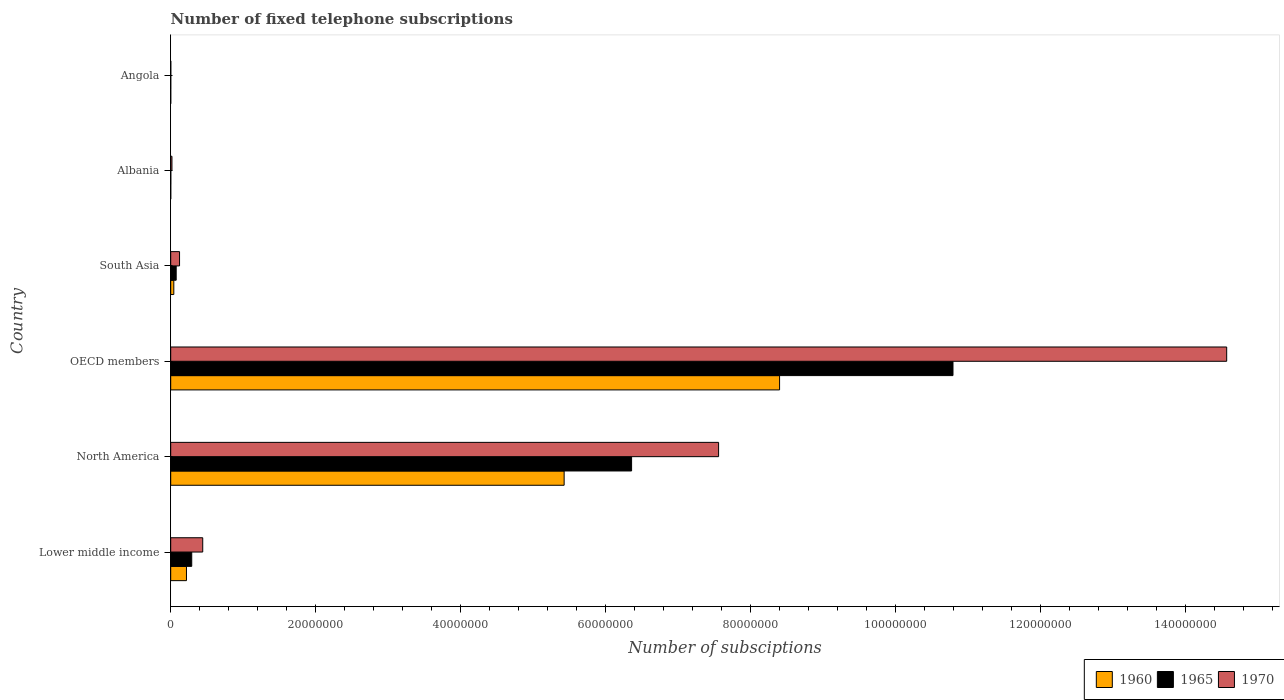How many different coloured bars are there?
Provide a short and direct response. 3. Are the number of bars per tick equal to the number of legend labels?
Your response must be concise. Yes. What is the label of the 4th group of bars from the top?
Offer a very short reply. OECD members. What is the number of fixed telephone subscriptions in 1960 in Lower middle income?
Keep it short and to the point. 2.17e+06. Across all countries, what is the maximum number of fixed telephone subscriptions in 1965?
Your response must be concise. 1.08e+08. Across all countries, what is the minimum number of fixed telephone subscriptions in 1970?
Offer a terse response. 1.30e+04. In which country was the number of fixed telephone subscriptions in 1965 maximum?
Your response must be concise. OECD members. In which country was the number of fixed telephone subscriptions in 1970 minimum?
Make the answer very short. Angola. What is the total number of fixed telephone subscriptions in 1965 in the graph?
Your answer should be very brief. 1.75e+08. What is the difference between the number of fixed telephone subscriptions in 1965 in Angola and that in North America?
Make the answer very short. -6.36e+07. What is the difference between the number of fixed telephone subscriptions in 1970 in Albania and the number of fixed telephone subscriptions in 1965 in South Asia?
Offer a very short reply. -5.84e+05. What is the average number of fixed telephone subscriptions in 1965 per country?
Offer a terse response. 2.92e+07. What is the difference between the number of fixed telephone subscriptions in 1970 and number of fixed telephone subscriptions in 1965 in OECD members?
Ensure brevity in your answer.  3.78e+07. In how many countries, is the number of fixed telephone subscriptions in 1960 greater than 148000000 ?
Offer a very short reply. 0. What is the ratio of the number of fixed telephone subscriptions in 1960 in North America to that in OECD members?
Provide a short and direct response. 0.65. Is the number of fixed telephone subscriptions in 1970 in Lower middle income less than that in South Asia?
Your response must be concise. No. What is the difference between the highest and the second highest number of fixed telephone subscriptions in 1960?
Your answer should be compact. 2.97e+07. What is the difference between the highest and the lowest number of fixed telephone subscriptions in 1970?
Your response must be concise. 1.46e+08. In how many countries, is the number of fixed telephone subscriptions in 1960 greater than the average number of fixed telephone subscriptions in 1960 taken over all countries?
Offer a very short reply. 2. What does the 1st bar from the top in North America represents?
Ensure brevity in your answer.  1970. What does the 2nd bar from the bottom in North America represents?
Ensure brevity in your answer.  1965. Are all the bars in the graph horizontal?
Keep it short and to the point. Yes. What is the difference between two consecutive major ticks on the X-axis?
Make the answer very short. 2.00e+07. Are the values on the major ticks of X-axis written in scientific E-notation?
Provide a succinct answer. No. Does the graph contain any zero values?
Your answer should be compact. No. Where does the legend appear in the graph?
Make the answer very short. Bottom right. What is the title of the graph?
Your answer should be compact. Number of fixed telephone subscriptions. What is the label or title of the X-axis?
Ensure brevity in your answer.  Number of subsciptions. What is the label or title of the Y-axis?
Your response must be concise. Country. What is the Number of subsciptions in 1960 in Lower middle income?
Offer a terse response. 2.17e+06. What is the Number of subsciptions in 1965 in Lower middle income?
Keep it short and to the point. 2.90e+06. What is the Number of subsciptions in 1970 in Lower middle income?
Provide a succinct answer. 4.42e+06. What is the Number of subsciptions in 1960 in North America?
Your answer should be very brief. 5.43e+07. What is the Number of subsciptions of 1965 in North America?
Keep it short and to the point. 6.36e+07. What is the Number of subsciptions in 1970 in North America?
Offer a very short reply. 7.56e+07. What is the Number of subsciptions of 1960 in OECD members?
Offer a very short reply. 8.40e+07. What is the Number of subsciptions in 1965 in OECD members?
Your response must be concise. 1.08e+08. What is the Number of subsciptions of 1970 in OECD members?
Offer a very short reply. 1.46e+08. What is the Number of subsciptions of 1960 in South Asia?
Offer a very short reply. 4.30e+05. What is the Number of subsciptions of 1965 in South Asia?
Keep it short and to the point. 7.57e+05. What is the Number of subsciptions of 1970 in South Asia?
Offer a very short reply. 1.22e+06. What is the Number of subsciptions of 1960 in Albania?
Keep it short and to the point. 6845. What is the Number of subsciptions in 1965 in Albania?
Your response must be concise. 1.40e+04. What is the Number of subsciptions in 1970 in Albania?
Provide a short and direct response. 1.73e+05. What is the Number of subsciptions in 1960 in Angola?
Your response must be concise. 6666. What is the Number of subsciptions of 1965 in Angola?
Give a very brief answer. 10000. What is the Number of subsciptions of 1970 in Angola?
Your answer should be very brief. 1.30e+04. Across all countries, what is the maximum Number of subsciptions of 1960?
Ensure brevity in your answer.  8.40e+07. Across all countries, what is the maximum Number of subsciptions in 1965?
Your answer should be very brief. 1.08e+08. Across all countries, what is the maximum Number of subsciptions of 1970?
Offer a very short reply. 1.46e+08. Across all countries, what is the minimum Number of subsciptions of 1960?
Give a very brief answer. 6666. Across all countries, what is the minimum Number of subsciptions in 1965?
Your answer should be compact. 10000. Across all countries, what is the minimum Number of subsciptions of 1970?
Offer a terse response. 1.30e+04. What is the total Number of subsciptions in 1960 in the graph?
Keep it short and to the point. 1.41e+08. What is the total Number of subsciptions of 1965 in the graph?
Offer a very short reply. 1.75e+08. What is the total Number of subsciptions of 1970 in the graph?
Offer a very short reply. 2.27e+08. What is the difference between the Number of subsciptions in 1960 in Lower middle income and that in North America?
Provide a short and direct response. -5.21e+07. What is the difference between the Number of subsciptions in 1965 in Lower middle income and that in North America?
Provide a short and direct response. -6.07e+07. What is the difference between the Number of subsciptions in 1970 in Lower middle income and that in North America?
Give a very brief answer. -7.12e+07. What is the difference between the Number of subsciptions in 1960 in Lower middle income and that in OECD members?
Give a very brief answer. -8.18e+07. What is the difference between the Number of subsciptions in 1965 in Lower middle income and that in OECD members?
Your answer should be very brief. -1.05e+08. What is the difference between the Number of subsciptions in 1970 in Lower middle income and that in OECD members?
Your answer should be compact. -1.41e+08. What is the difference between the Number of subsciptions in 1960 in Lower middle income and that in South Asia?
Make the answer very short. 1.74e+06. What is the difference between the Number of subsciptions in 1965 in Lower middle income and that in South Asia?
Your answer should be very brief. 2.14e+06. What is the difference between the Number of subsciptions of 1970 in Lower middle income and that in South Asia?
Give a very brief answer. 3.20e+06. What is the difference between the Number of subsciptions in 1960 in Lower middle income and that in Albania?
Provide a succinct answer. 2.17e+06. What is the difference between the Number of subsciptions of 1965 in Lower middle income and that in Albania?
Offer a very short reply. 2.89e+06. What is the difference between the Number of subsciptions of 1970 in Lower middle income and that in Albania?
Your response must be concise. 4.25e+06. What is the difference between the Number of subsciptions of 1960 in Lower middle income and that in Angola?
Provide a succinct answer. 2.17e+06. What is the difference between the Number of subsciptions in 1965 in Lower middle income and that in Angola?
Offer a very short reply. 2.89e+06. What is the difference between the Number of subsciptions of 1970 in Lower middle income and that in Angola?
Provide a succinct answer. 4.41e+06. What is the difference between the Number of subsciptions of 1960 in North America and that in OECD members?
Make the answer very short. -2.97e+07. What is the difference between the Number of subsciptions of 1965 in North America and that in OECD members?
Keep it short and to the point. -4.43e+07. What is the difference between the Number of subsciptions of 1970 in North America and that in OECD members?
Your response must be concise. -7.01e+07. What is the difference between the Number of subsciptions in 1960 in North America and that in South Asia?
Provide a succinct answer. 5.38e+07. What is the difference between the Number of subsciptions of 1965 in North America and that in South Asia?
Provide a short and direct response. 6.28e+07. What is the difference between the Number of subsciptions in 1970 in North America and that in South Asia?
Give a very brief answer. 7.43e+07. What is the difference between the Number of subsciptions of 1960 in North America and that in Albania?
Give a very brief answer. 5.43e+07. What is the difference between the Number of subsciptions in 1965 in North America and that in Albania?
Your answer should be compact. 6.36e+07. What is the difference between the Number of subsciptions in 1970 in North America and that in Albania?
Provide a succinct answer. 7.54e+07. What is the difference between the Number of subsciptions in 1960 in North America and that in Angola?
Your answer should be very brief. 5.43e+07. What is the difference between the Number of subsciptions of 1965 in North America and that in Angola?
Ensure brevity in your answer.  6.36e+07. What is the difference between the Number of subsciptions of 1970 in North America and that in Angola?
Provide a short and direct response. 7.56e+07. What is the difference between the Number of subsciptions of 1960 in OECD members and that in South Asia?
Offer a very short reply. 8.36e+07. What is the difference between the Number of subsciptions of 1965 in OECD members and that in South Asia?
Offer a very short reply. 1.07e+08. What is the difference between the Number of subsciptions of 1970 in OECD members and that in South Asia?
Your answer should be compact. 1.44e+08. What is the difference between the Number of subsciptions of 1960 in OECD members and that in Albania?
Make the answer very short. 8.40e+07. What is the difference between the Number of subsciptions in 1965 in OECD members and that in Albania?
Provide a succinct answer. 1.08e+08. What is the difference between the Number of subsciptions in 1970 in OECD members and that in Albania?
Provide a succinct answer. 1.45e+08. What is the difference between the Number of subsciptions in 1960 in OECD members and that in Angola?
Your answer should be very brief. 8.40e+07. What is the difference between the Number of subsciptions of 1965 in OECD members and that in Angola?
Your answer should be compact. 1.08e+08. What is the difference between the Number of subsciptions of 1970 in OECD members and that in Angola?
Your response must be concise. 1.46e+08. What is the difference between the Number of subsciptions in 1960 in South Asia and that in Albania?
Ensure brevity in your answer.  4.23e+05. What is the difference between the Number of subsciptions of 1965 in South Asia and that in Albania?
Your response must be concise. 7.43e+05. What is the difference between the Number of subsciptions of 1970 in South Asia and that in Albania?
Provide a succinct answer. 1.05e+06. What is the difference between the Number of subsciptions in 1960 in South Asia and that in Angola?
Provide a short and direct response. 4.23e+05. What is the difference between the Number of subsciptions of 1965 in South Asia and that in Angola?
Offer a terse response. 7.47e+05. What is the difference between the Number of subsciptions in 1970 in South Asia and that in Angola?
Provide a succinct answer. 1.21e+06. What is the difference between the Number of subsciptions in 1960 in Albania and that in Angola?
Ensure brevity in your answer.  179. What is the difference between the Number of subsciptions of 1965 in Albania and that in Angola?
Offer a very short reply. 3991. What is the difference between the Number of subsciptions in 1970 in Albania and that in Angola?
Give a very brief answer. 1.60e+05. What is the difference between the Number of subsciptions in 1960 in Lower middle income and the Number of subsciptions in 1965 in North America?
Offer a terse response. -6.14e+07. What is the difference between the Number of subsciptions in 1960 in Lower middle income and the Number of subsciptions in 1970 in North America?
Keep it short and to the point. -7.34e+07. What is the difference between the Number of subsciptions in 1965 in Lower middle income and the Number of subsciptions in 1970 in North America?
Give a very brief answer. -7.27e+07. What is the difference between the Number of subsciptions of 1960 in Lower middle income and the Number of subsciptions of 1965 in OECD members?
Your answer should be very brief. -1.06e+08. What is the difference between the Number of subsciptions in 1960 in Lower middle income and the Number of subsciptions in 1970 in OECD members?
Provide a short and direct response. -1.43e+08. What is the difference between the Number of subsciptions of 1965 in Lower middle income and the Number of subsciptions of 1970 in OECD members?
Ensure brevity in your answer.  -1.43e+08. What is the difference between the Number of subsciptions in 1960 in Lower middle income and the Number of subsciptions in 1965 in South Asia?
Give a very brief answer. 1.42e+06. What is the difference between the Number of subsciptions of 1960 in Lower middle income and the Number of subsciptions of 1970 in South Asia?
Your answer should be compact. 9.54e+05. What is the difference between the Number of subsciptions in 1965 in Lower middle income and the Number of subsciptions in 1970 in South Asia?
Your answer should be very brief. 1.68e+06. What is the difference between the Number of subsciptions of 1960 in Lower middle income and the Number of subsciptions of 1965 in Albania?
Ensure brevity in your answer.  2.16e+06. What is the difference between the Number of subsciptions in 1960 in Lower middle income and the Number of subsciptions in 1970 in Albania?
Your response must be concise. 2.00e+06. What is the difference between the Number of subsciptions of 1965 in Lower middle income and the Number of subsciptions of 1970 in Albania?
Your response must be concise. 2.73e+06. What is the difference between the Number of subsciptions of 1960 in Lower middle income and the Number of subsciptions of 1965 in Angola?
Keep it short and to the point. 2.16e+06. What is the difference between the Number of subsciptions of 1960 in Lower middle income and the Number of subsciptions of 1970 in Angola?
Your answer should be compact. 2.16e+06. What is the difference between the Number of subsciptions in 1965 in Lower middle income and the Number of subsciptions in 1970 in Angola?
Make the answer very short. 2.89e+06. What is the difference between the Number of subsciptions of 1960 in North America and the Number of subsciptions of 1965 in OECD members?
Offer a terse response. -5.36e+07. What is the difference between the Number of subsciptions of 1960 in North America and the Number of subsciptions of 1970 in OECD members?
Give a very brief answer. -9.14e+07. What is the difference between the Number of subsciptions in 1965 in North America and the Number of subsciptions in 1970 in OECD members?
Ensure brevity in your answer.  -8.21e+07. What is the difference between the Number of subsciptions in 1960 in North America and the Number of subsciptions in 1965 in South Asia?
Your answer should be very brief. 5.35e+07. What is the difference between the Number of subsciptions in 1960 in North America and the Number of subsciptions in 1970 in South Asia?
Keep it short and to the point. 5.30e+07. What is the difference between the Number of subsciptions of 1965 in North America and the Number of subsciptions of 1970 in South Asia?
Your answer should be very brief. 6.24e+07. What is the difference between the Number of subsciptions in 1960 in North America and the Number of subsciptions in 1965 in Albania?
Offer a very short reply. 5.43e+07. What is the difference between the Number of subsciptions of 1960 in North America and the Number of subsciptions of 1970 in Albania?
Keep it short and to the point. 5.41e+07. What is the difference between the Number of subsciptions in 1965 in North America and the Number of subsciptions in 1970 in Albania?
Your response must be concise. 6.34e+07. What is the difference between the Number of subsciptions in 1960 in North America and the Number of subsciptions in 1965 in Angola?
Offer a terse response. 5.43e+07. What is the difference between the Number of subsciptions in 1960 in North America and the Number of subsciptions in 1970 in Angola?
Your response must be concise. 5.43e+07. What is the difference between the Number of subsciptions in 1965 in North America and the Number of subsciptions in 1970 in Angola?
Your response must be concise. 6.36e+07. What is the difference between the Number of subsciptions in 1960 in OECD members and the Number of subsciptions in 1965 in South Asia?
Make the answer very short. 8.32e+07. What is the difference between the Number of subsciptions of 1960 in OECD members and the Number of subsciptions of 1970 in South Asia?
Make the answer very short. 8.28e+07. What is the difference between the Number of subsciptions of 1965 in OECD members and the Number of subsciptions of 1970 in South Asia?
Provide a succinct answer. 1.07e+08. What is the difference between the Number of subsciptions in 1960 in OECD members and the Number of subsciptions in 1965 in Albania?
Your answer should be compact. 8.40e+07. What is the difference between the Number of subsciptions in 1960 in OECD members and the Number of subsciptions in 1970 in Albania?
Provide a short and direct response. 8.38e+07. What is the difference between the Number of subsciptions in 1965 in OECD members and the Number of subsciptions in 1970 in Albania?
Provide a short and direct response. 1.08e+08. What is the difference between the Number of subsciptions in 1960 in OECD members and the Number of subsciptions in 1965 in Angola?
Offer a terse response. 8.40e+07. What is the difference between the Number of subsciptions in 1960 in OECD members and the Number of subsciptions in 1970 in Angola?
Provide a short and direct response. 8.40e+07. What is the difference between the Number of subsciptions of 1965 in OECD members and the Number of subsciptions of 1970 in Angola?
Your answer should be compact. 1.08e+08. What is the difference between the Number of subsciptions in 1960 in South Asia and the Number of subsciptions in 1965 in Albania?
Give a very brief answer. 4.16e+05. What is the difference between the Number of subsciptions in 1960 in South Asia and the Number of subsciptions in 1970 in Albania?
Your answer should be compact. 2.57e+05. What is the difference between the Number of subsciptions in 1965 in South Asia and the Number of subsciptions in 1970 in Albania?
Offer a very short reply. 5.84e+05. What is the difference between the Number of subsciptions of 1960 in South Asia and the Number of subsciptions of 1965 in Angola?
Offer a terse response. 4.20e+05. What is the difference between the Number of subsciptions in 1960 in South Asia and the Number of subsciptions in 1970 in Angola?
Make the answer very short. 4.17e+05. What is the difference between the Number of subsciptions of 1965 in South Asia and the Number of subsciptions of 1970 in Angola?
Keep it short and to the point. 7.44e+05. What is the difference between the Number of subsciptions in 1960 in Albania and the Number of subsciptions in 1965 in Angola?
Give a very brief answer. -3155. What is the difference between the Number of subsciptions in 1960 in Albania and the Number of subsciptions in 1970 in Angola?
Offer a terse response. -6155. What is the difference between the Number of subsciptions in 1965 in Albania and the Number of subsciptions in 1970 in Angola?
Provide a succinct answer. 991. What is the average Number of subsciptions in 1960 per country?
Your answer should be very brief. 2.35e+07. What is the average Number of subsciptions of 1965 per country?
Your response must be concise. 2.92e+07. What is the average Number of subsciptions of 1970 per country?
Your answer should be compact. 3.78e+07. What is the difference between the Number of subsciptions of 1960 and Number of subsciptions of 1965 in Lower middle income?
Offer a very short reply. -7.27e+05. What is the difference between the Number of subsciptions of 1960 and Number of subsciptions of 1970 in Lower middle income?
Your response must be concise. -2.24e+06. What is the difference between the Number of subsciptions in 1965 and Number of subsciptions in 1970 in Lower middle income?
Offer a very short reply. -1.52e+06. What is the difference between the Number of subsciptions in 1960 and Number of subsciptions in 1965 in North America?
Your answer should be very brief. -9.30e+06. What is the difference between the Number of subsciptions of 1960 and Number of subsciptions of 1970 in North America?
Make the answer very short. -2.13e+07. What is the difference between the Number of subsciptions in 1965 and Number of subsciptions in 1970 in North America?
Make the answer very short. -1.20e+07. What is the difference between the Number of subsciptions in 1960 and Number of subsciptions in 1965 in OECD members?
Give a very brief answer. -2.39e+07. What is the difference between the Number of subsciptions in 1960 and Number of subsciptions in 1970 in OECD members?
Your response must be concise. -6.17e+07. What is the difference between the Number of subsciptions of 1965 and Number of subsciptions of 1970 in OECD members?
Your answer should be compact. -3.78e+07. What is the difference between the Number of subsciptions of 1960 and Number of subsciptions of 1965 in South Asia?
Your answer should be very brief. -3.27e+05. What is the difference between the Number of subsciptions of 1960 and Number of subsciptions of 1970 in South Asia?
Offer a very short reply. -7.90e+05. What is the difference between the Number of subsciptions of 1965 and Number of subsciptions of 1970 in South Asia?
Your answer should be compact. -4.63e+05. What is the difference between the Number of subsciptions of 1960 and Number of subsciptions of 1965 in Albania?
Ensure brevity in your answer.  -7146. What is the difference between the Number of subsciptions in 1960 and Number of subsciptions in 1970 in Albania?
Provide a succinct answer. -1.66e+05. What is the difference between the Number of subsciptions of 1965 and Number of subsciptions of 1970 in Albania?
Provide a succinct answer. -1.59e+05. What is the difference between the Number of subsciptions in 1960 and Number of subsciptions in 1965 in Angola?
Offer a terse response. -3334. What is the difference between the Number of subsciptions of 1960 and Number of subsciptions of 1970 in Angola?
Provide a short and direct response. -6334. What is the difference between the Number of subsciptions in 1965 and Number of subsciptions in 1970 in Angola?
Give a very brief answer. -3000. What is the ratio of the Number of subsciptions of 1960 in Lower middle income to that in North America?
Your response must be concise. 0.04. What is the ratio of the Number of subsciptions in 1965 in Lower middle income to that in North America?
Keep it short and to the point. 0.05. What is the ratio of the Number of subsciptions in 1970 in Lower middle income to that in North America?
Provide a short and direct response. 0.06. What is the ratio of the Number of subsciptions in 1960 in Lower middle income to that in OECD members?
Ensure brevity in your answer.  0.03. What is the ratio of the Number of subsciptions of 1965 in Lower middle income to that in OECD members?
Ensure brevity in your answer.  0.03. What is the ratio of the Number of subsciptions in 1970 in Lower middle income to that in OECD members?
Offer a terse response. 0.03. What is the ratio of the Number of subsciptions of 1960 in Lower middle income to that in South Asia?
Give a very brief answer. 5.06. What is the ratio of the Number of subsciptions of 1965 in Lower middle income to that in South Asia?
Offer a terse response. 3.83. What is the ratio of the Number of subsciptions of 1970 in Lower middle income to that in South Asia?
Offer a terse response. 3.62. What is the ratio of the Number of subsciptions of 1960 in Lower middle income to that in Albania?
Provide a succinct answer. 317.63. What is the ratio of the Number of subsciptions of 1965 in Lower middle income to that in Albania?
Make the answer very short. 207.34. What is the ratio of the Number of subsciptions in 1970 in Lower middle income to that in Albania?
Offer a terse response. 25.54. What is the ratio of the Number of subsciptions of 1960 in Lower middle income to that in Angola?
Offer a terse response. 326.16. What is the ratio of the Number of subsciptions of 1965 in Lower middle income to that in Angola?
Your answer should be very brief. 290.09. What is the ratio of the Number of subsciptions in 1970 in Lower middle income to that in Angola?
Make the answer very short. 339.85. What is the ratio of the Number of subsciptions in 1960 in North America to that in OECD members?
Provide a short and direct response. 0.65. What is the ratio of the Number of subsciptions in 1965 in North America to that in OECD members?
Keep it short and to the point. 0.59. What is the ratio of the Number of subsciptions in 1970 in North America to that in OECD members?
Keep it short and to the point. 0.52. What is the ratio of the Number of subsciptions of 1960 in North America to that in South Asia?
Your response must be concise. 126.3. What is the ratio of the Number of subsciptions in 1965 in North America to that in South Asia?
Offer a very short reply. 84.02. What is the ratio of the Number of subsciptions in 1970 in North America to that in South Asia?
Make the answer very short. 61.94. What is the ratio of the Number of subsciptions in 1960 in North America to that in Albania?
Offer a terse response. 7927.8. What is the ratio of the Number of subsciptions of 1965 in North America to that in Albania?
Offer a terse response. 4543.67. What is the ratio of the Number of subsciptions in 1970 in North America to that in Albania?
Ensure brevity in your answer.  436.82. What is the ratio of the Number of subsciptions of 1960 in North America to that in Angola?
Make the answer very short. 8140.68. What is the ratio of the Number of subsciptions in 1965 in North America to that in Angola?
Offer a very short reply. 6357.05. What is the ratio of the Number of subsciptions in 1970 in North America to that in Angola?
Your answer should be very brief. 5813. What is the ratio of the Number of subsciptions of 1960 in OECD members to that in South Asia?
Give a very brief answer. 195.46. What is the ratio of the Number of subsciptions of 1965 in OECD members to that in South Asia?
Ensure brevity in your answer.  142.6. What is the ratio of the Number of subsciptions of 1970 in OECD members to that in South Asia?
Offer a terse response. 119.38. What is the ratio of the Number of subsciptions of 1960 in OECD members to that in Albania?
Your response must be concise. 1.23e+04. What is the ratio of the Number of subsciptions of 1965 in OECD members to that in Albania?
Offer a terse response. 7711.94. What is the ratio of the Number of subsciptions in 1970 in OECD members to that in Albania?
Make the answer very short. 841.91. What is the ratio of the Number of subsciptions of 1960 in OECD members to that in Angola?
Offer a terse response. 1.26e+04. What is the ratio of the Number of subsciptions of 1965 in OECD members to that in Angola?
Provide a short and direct response. 1.08e+04. What is the ratio of the Number of subsciptions in 1970 in OECD members to that in Angola?
Keep it short and to the point. 1.12e+04. What is the ratio of the Number of subsciptions of 1960 in South Asia to that in Albania?
Offer a very short reply. 62.77. What is the ratio of the Number of subsciptions in 1965 in South Asia to that in Albania?
Ensure brevity in your answer.  54.08. What is the ratio of the Number of subsciptions in 1970 in South Asia to that in Albania?
Provide a succinct answer. 7.05. What is the ratio of the Number of subsciptions of 1960 in South Asia to that in Angola?
Your answer should be very brief. 64.45. What is the ratio of the Number of subsciptions in 1965 in South Asia to that in Angola?
Ensure brevity in your answer.  75.66. What is the ratio of the Number of subsciptions of 1970 in South Asia to that in Angola?
Provide a short and direct response. 93.85. What is the ratio of the Number of subsciptions of 1960 in Albania to that in Angola?
Offer a terse response. 1.03. What is the ratio of the Number of subsciptions in 1965 in Albania to that in Angola?
Ensure brevity in your answer.  1.4. What is the ratio of the Number of subsciptions of 1970 in Albania to that in Angola?
Keep it short and to the point. 13.31. What is the difference between the highest and the second highest Number of subsciptions of 1960?
Keep it short and to the point. 2.97e+07. What is the difference between the highest and the second highest Number of subsciptions of 1965?
Offer a very short reply. 4.43e+07. What is the difference between the highest and the second highest Number of subsciptions of 1970?
Make the answer very short. 7.01e+07. What is the difference between the highest and the lowest Number of subsciptions in 1960?
Offer a terse response. 8.40e+07. What is the difference between the highest and the lowest Number of subsciptions in 1965?
Your answer should be very brief. 1.08e+08. What is the difference between the highest and the lowest Number of subsciptions in 1970?
Offer a terse response. 1.46e+08. 